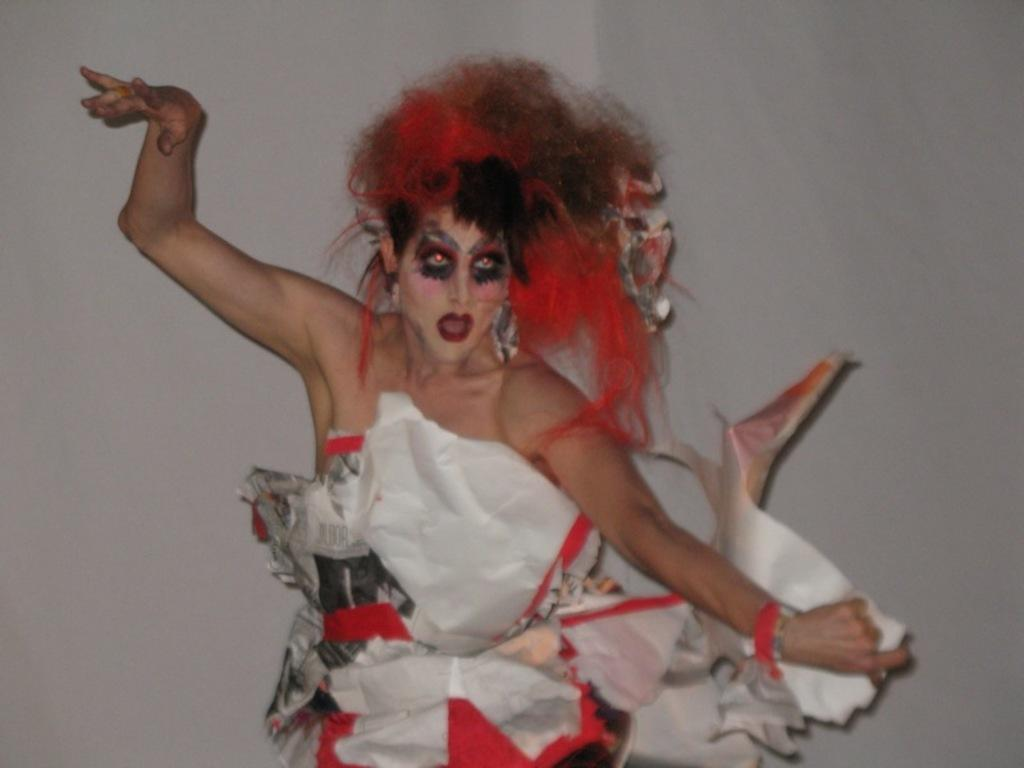What is the main subject of the image? There is a woman in the image. What is the woman doing in the image? The woman is dancing. Can you describe any additional features on the woman? The woman has a painting on her face and is wearing a fancy dress. What can be seen in the background of the image? There is a white wall in the background of the image. What type of trousers is the woman wearing in the image? The image does not show the woman wearing trousers; she is wearing a fancy dress. What sound can be heard coming from the woman in the image? The image is a still image, so no sound can be heard. 